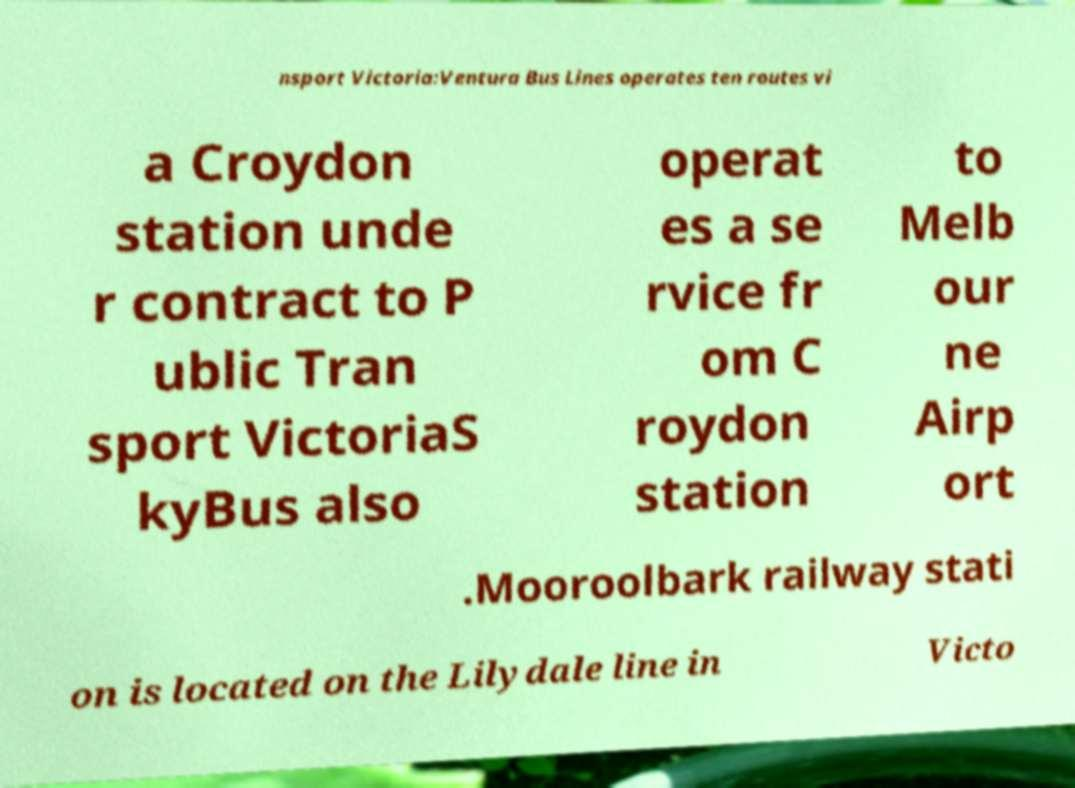Can you accurately transcribe the text from the provided image for me? nsport Victoria:Ventura Bus Lines operates ten routes vi a Croydon station unde r contract to P ublic Tran sport VictoriaS kyBus also operat es a se rvice fr om C roydon station to Melb our ne Airp ort .Mooroolbark railway stati on is located on the Lilydale line in Victo 